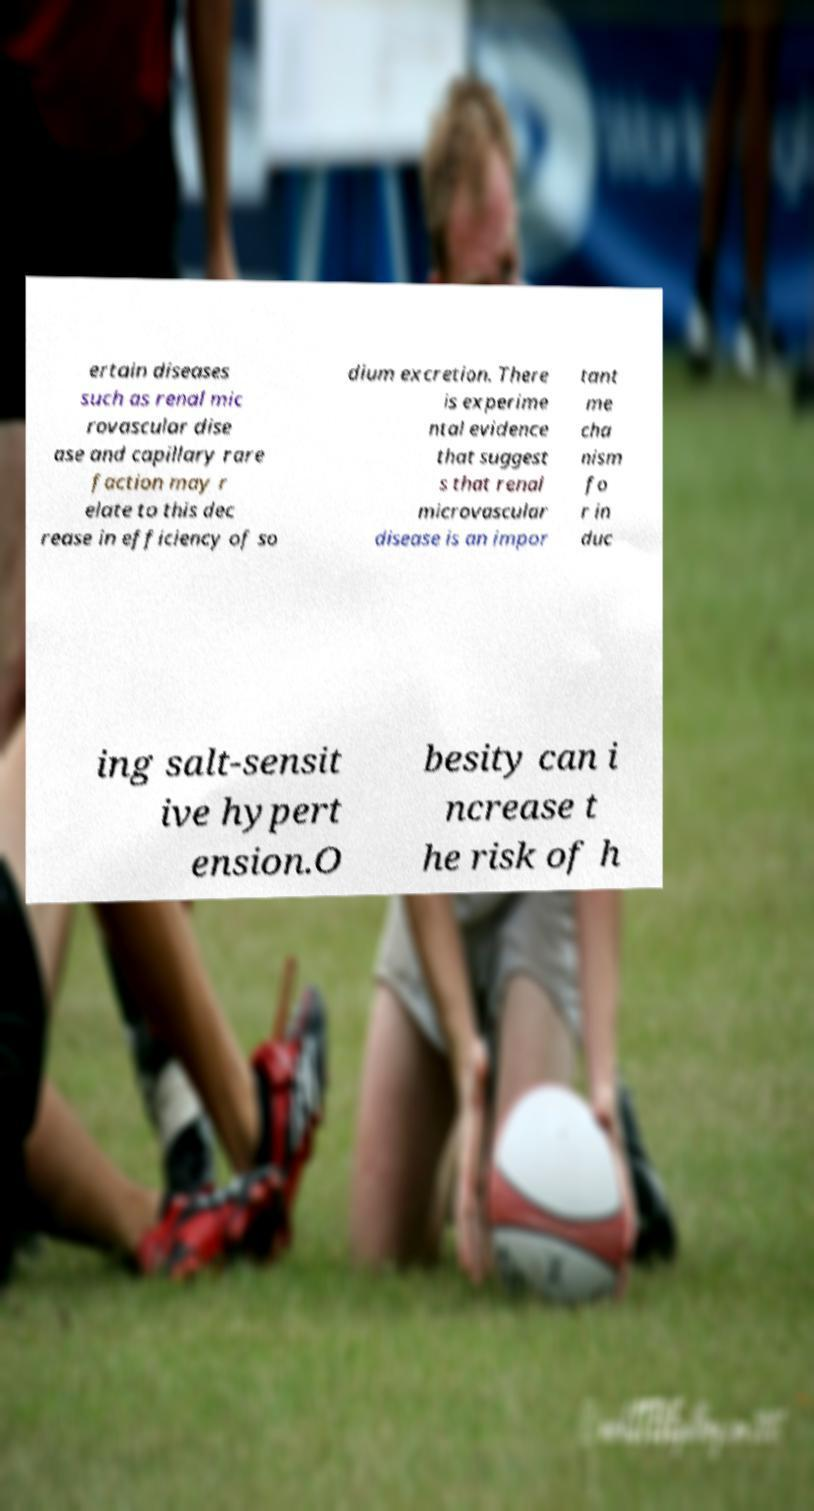I need the written content from this picture converted into text. Can you do that? ertain diseases such as renal mic rovascular dise ase and capillary rare faction may r elate to this dec rease in efficiency of so dium excretion. There is experime ntal evidence that suggest s that renal microvascular disease is an impor tant me cha nism fo r in duc ing salt-sensit ive hypert ension.O besity can i ncrease t he risk of h 